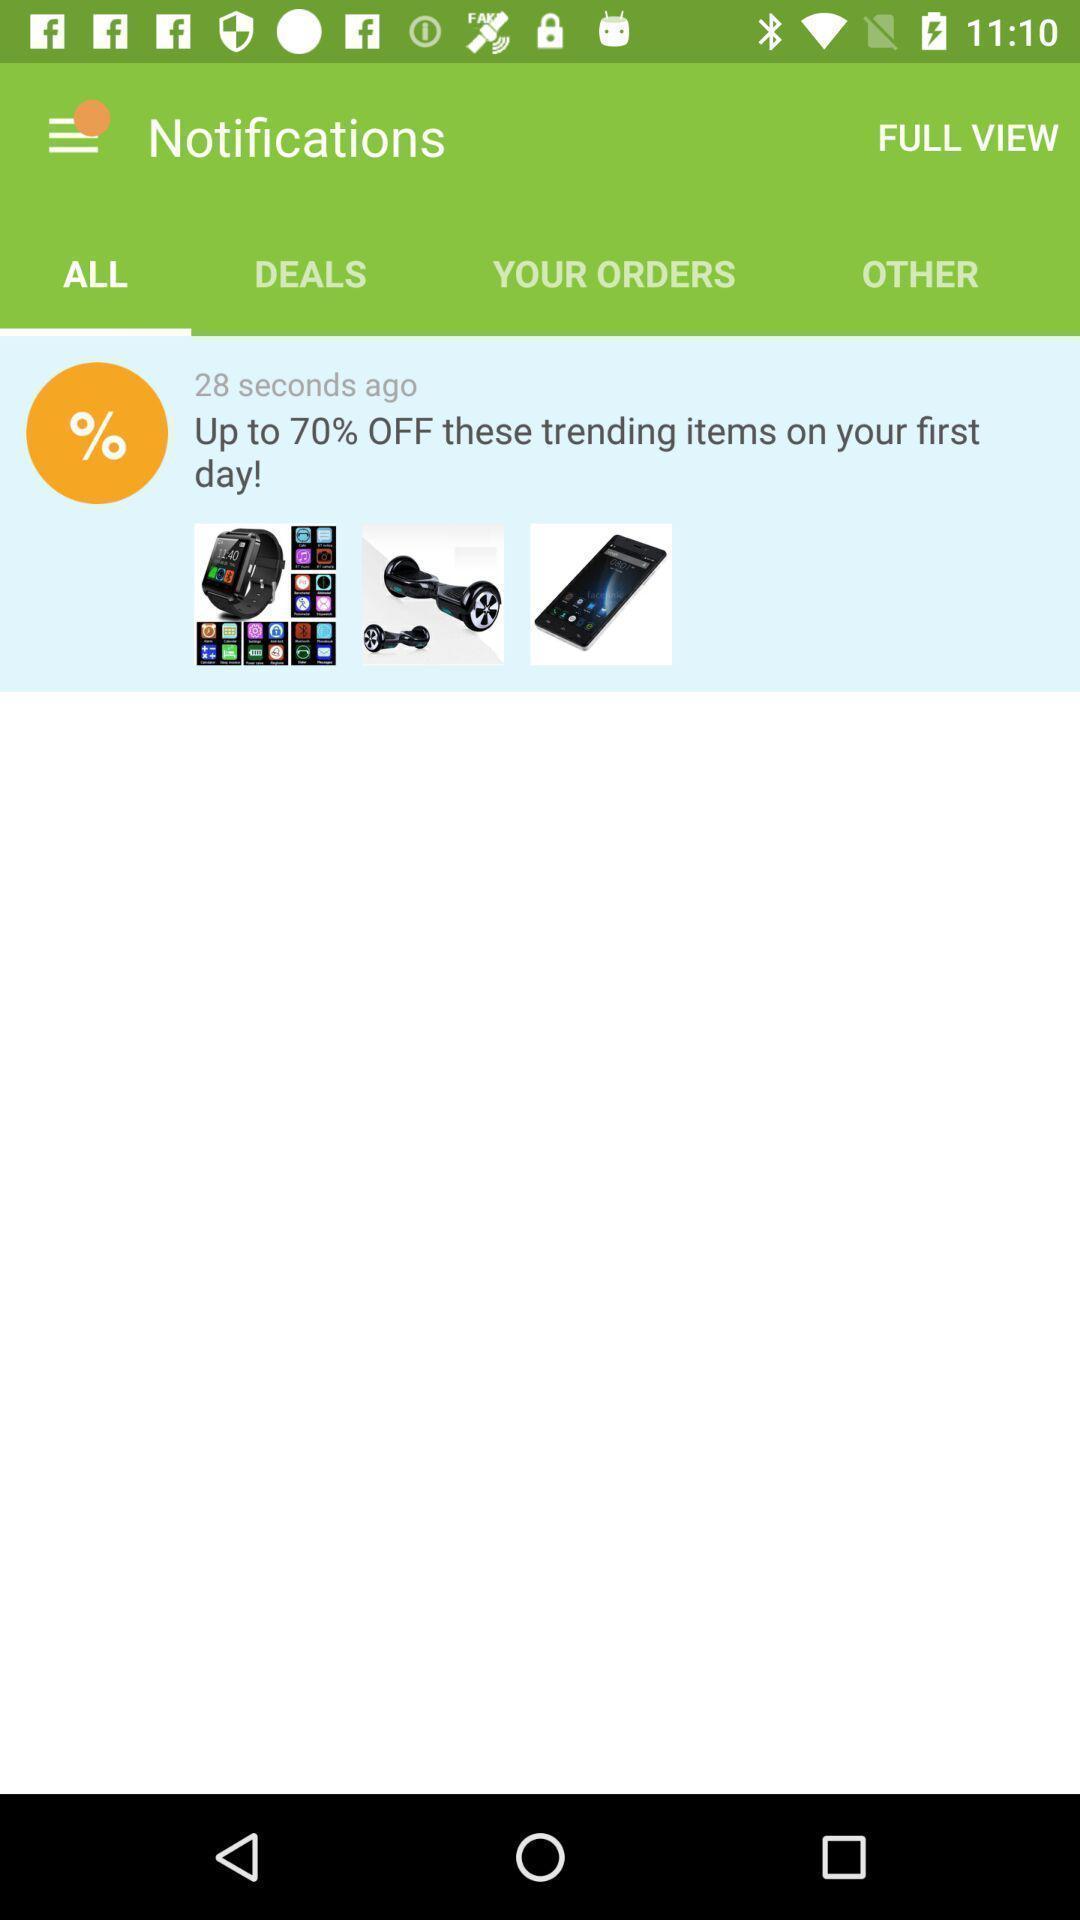Describe the visual elements of this screenshot. Page shows the notifications of trending products. 